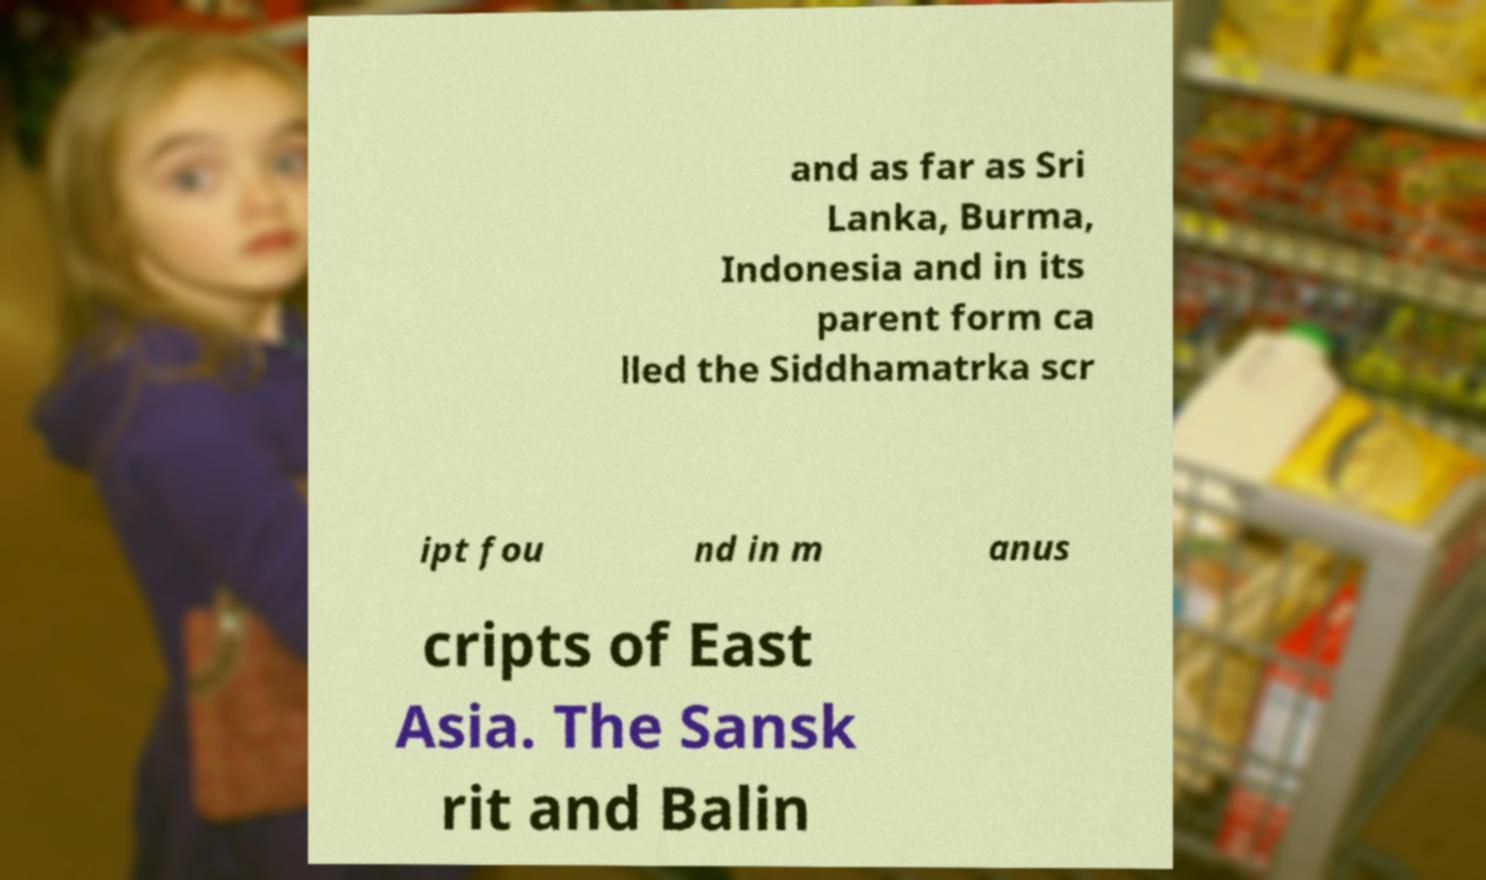Please identify and transcribe the text found in this image. and as far as Sri Lanka, Burma, Indonesia and in its parent form ca lled the Siddhamatrka scr ipt fou nd in m anus cripts of East Asia. The Sansk rit and Balin 